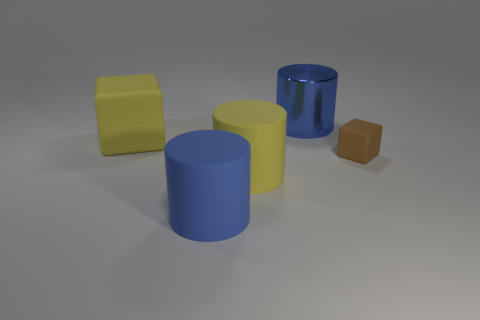Do the large matte block and the big rubber object on the right side of the large blue matte thing have the same color?
Your response must be concise. Yes. What number of other things are there of the same material as the tiny brown cube
Your answer should be compact. 3. Does the brown thing have the same material as the large blue thing to the right of the big yellow cylinder?
Keep it short and to the point. No. Is there anything else of the same color as the small block?
Your answer should be compact. No. Is the number of large blue matte cylinders that are behind the yellow matte block less than the number of small yellow metal cylinders?
Keep it short and to the point. No. What number of rubber blocks have the same size as the yellow cylinder?
Offer a very short reply. 1. There is a matte object that is the same color as the shiny thing; what shape is it?
Offer a very short reply. Cylinder. There is a big yellow thing left of the large blue object that is on the left side of the blue cylinder to the right of the big yellow matte cylinder; what shape is it?
Offer a very short reply. Cube. There is a large rubber cylinder behind the large blue matte cylinder; what is its color?
Provide a short and direct response. Yellow. How many things are matte objects that are behind the brown object or matte things that are right of the large blue matte object?
Give a very brief answer. 3. 